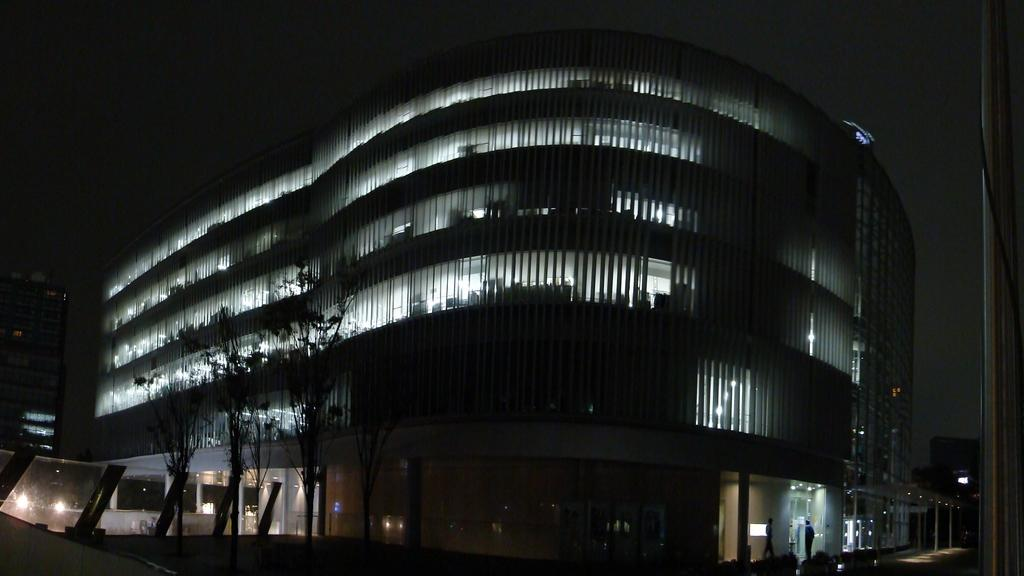What is the main structure in the middle of the image? There is a building in the middle of the image. What can be observed about the lighting in the top part of the image? The top part of the image is dark. What type of vegetation is on the left side of the image? There are trees on the left side of the image. What is present on the left side of the image besides trees? There are lights on the left side of the image. What can be seen on the right side of the road in the image? There are plants on the right side of the road in the image. Can you tell me how many wrens are perched on the hose in the image? There is no hose or wrens present in the image. What type of road is visible in the image? The image does not show a road; it features a building, trees, lights, and plants. 